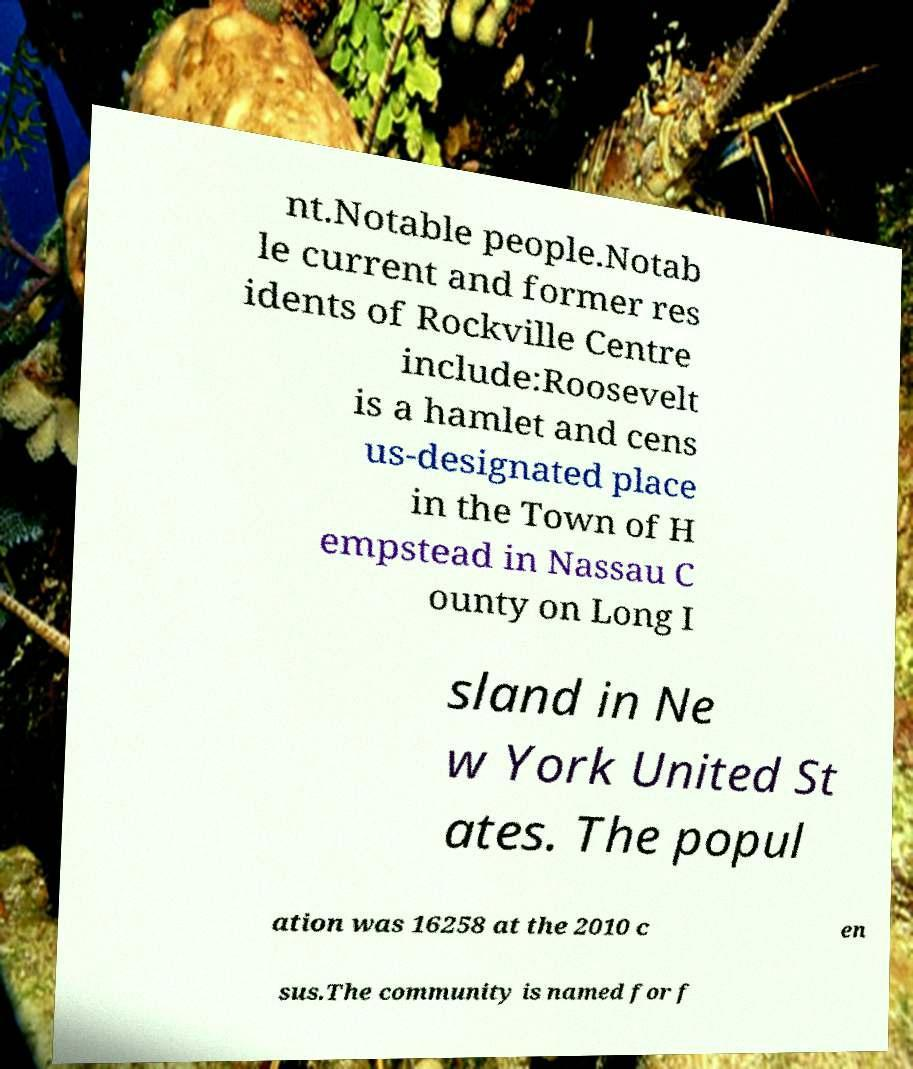I need the written content from this picture converted into text. Can you do that? nt.Notable people.Notab le current and former res idents of Rockville Centre include:Roosevelt is a hamlet and cens us-designated place in the Town of H empstead in Nassau C ounty on Long I sland in Ne w York United St ates. The popul ation was 16258 at the 2010 c en sus.The community is named for f 